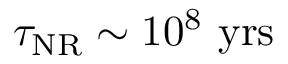<formula> <loc_0><loc_0><loc_500><loc_500>\tau _ { N R } \sim 1 0 ^ { 8 } y r s</formula> 